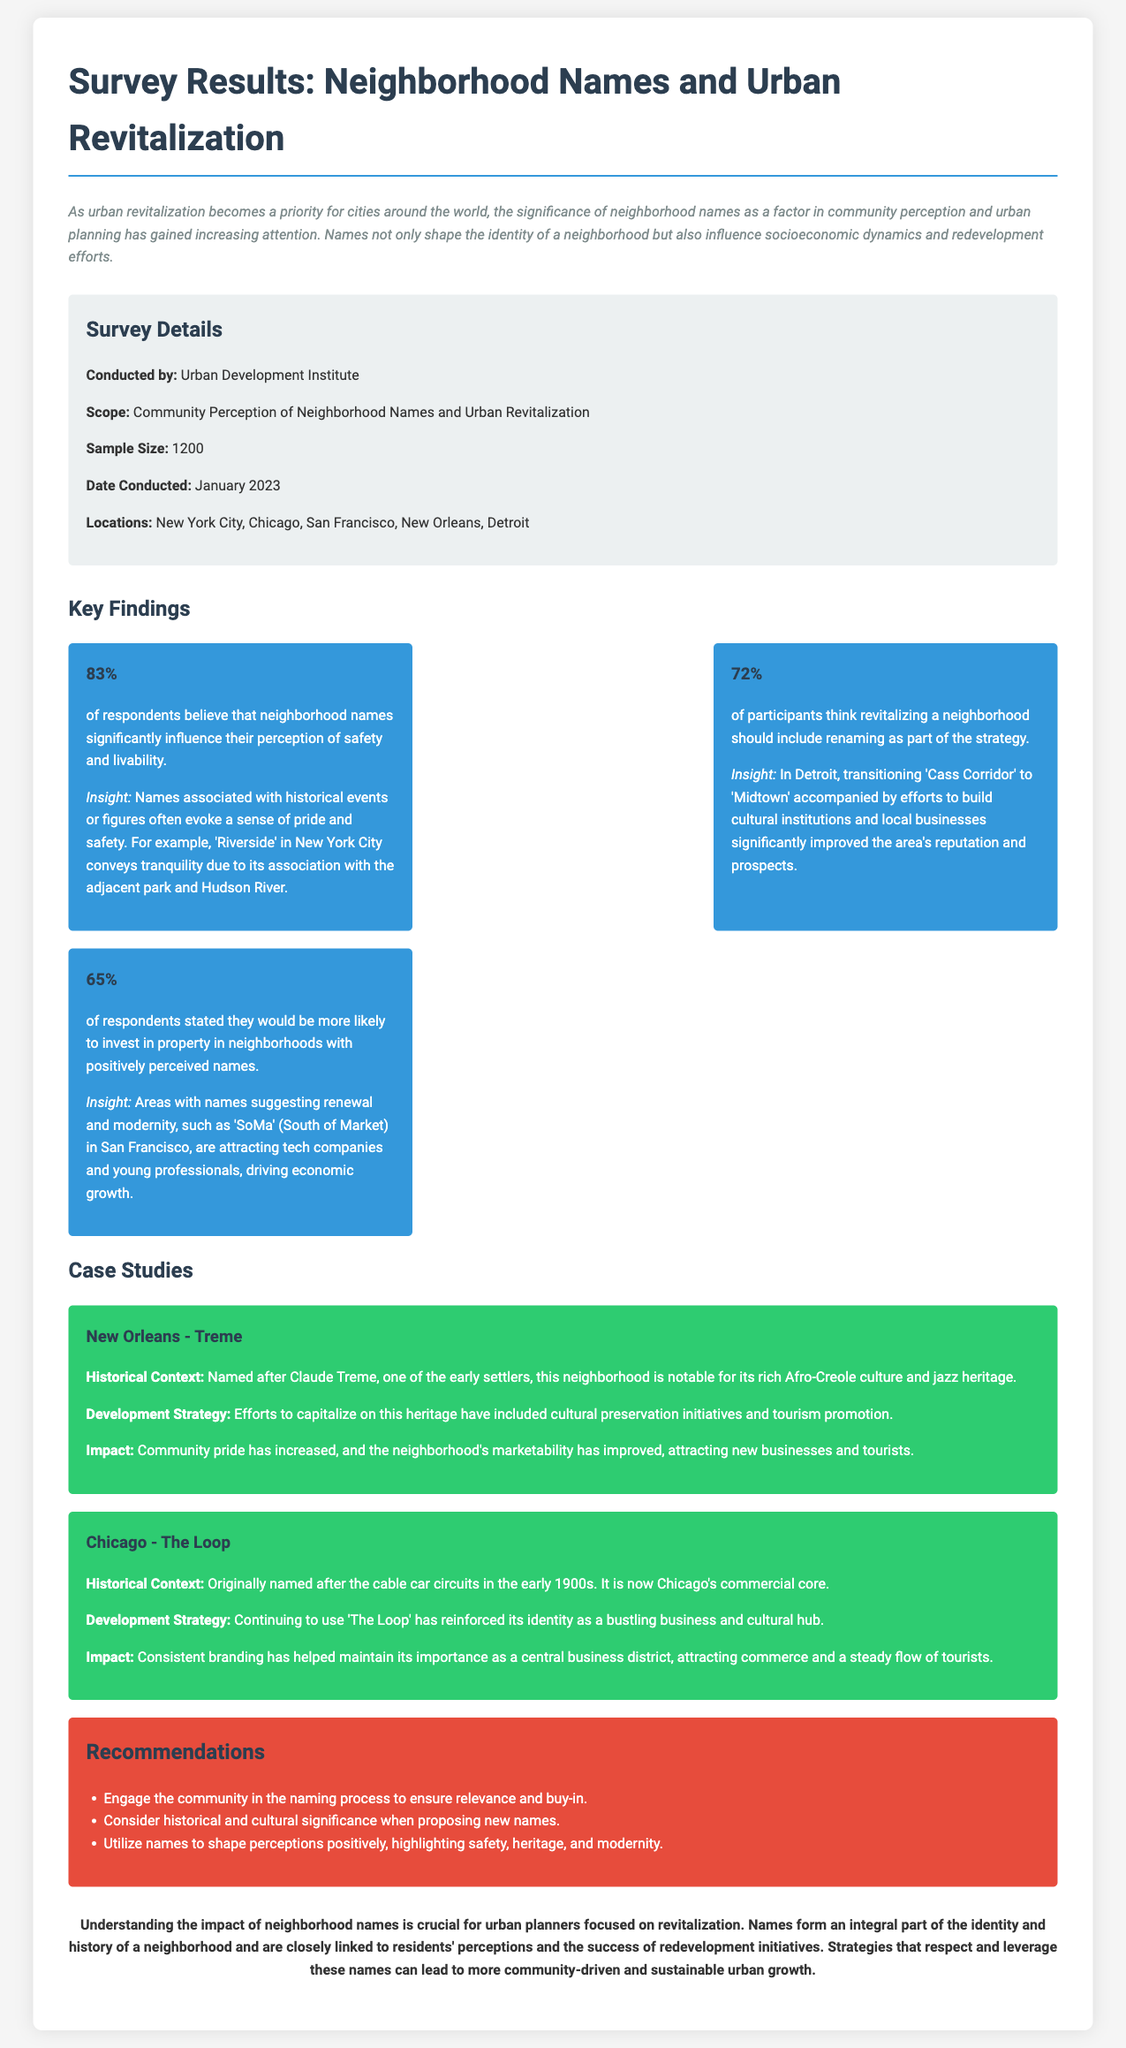What organization conducted the survey? The organization that conducted the survey is mentioned in the survey details section.
Answer: Urban Development Institute What was the sample size of the survey? The sample size is explicitly stated in the survey details section.
Answer: 1200 What percentage of respondents believes neighborhood names influence their perception of safety? This percentage is provided in the key findings section regarding perceptions related to safety and livability.
Answer: 83% Which neighborhood's name change significantly improved its reputation according to the findings? This is discussed in the insights of a key finding related to revitalization strategy.
Answer: Cass Corridor What aspect of neighborhood names does the conclusion emphasize for urban planners? The conclusion encapsulates a key theme regarding the role of names in planning.
Answer: Identity and history How long after the survey was conducted was the document created? The date conducted is provided, and the assumed document creation date is shortly after that; therefore, we can calculate the time duration accordingly.
Answer: Less than a year What was the impact of using the name 'The Loop' in Chicago? The impact is discussed in the case study for Chicago, focusing on branding.
Answer: Maintain its importance What is the main recommendation regarding community involvement? This recommendation is listed under the recommendations section, emphasizing engaging community in processes.
Answer: Engage the community What unique cultural aspect does the Treme neighborhood in New Orleans have? The historical context of Treme mentions a notable cultural feature that distinguishes it.
Answer: Afro-Creole culture 